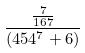<formula> <loc_0><loc_0><loc_500><loc_500>\frac { \frac { 7 } { 1 6 7 } } { ( 4 5 4 ^ { 7 } + 6 ) }</formula> 